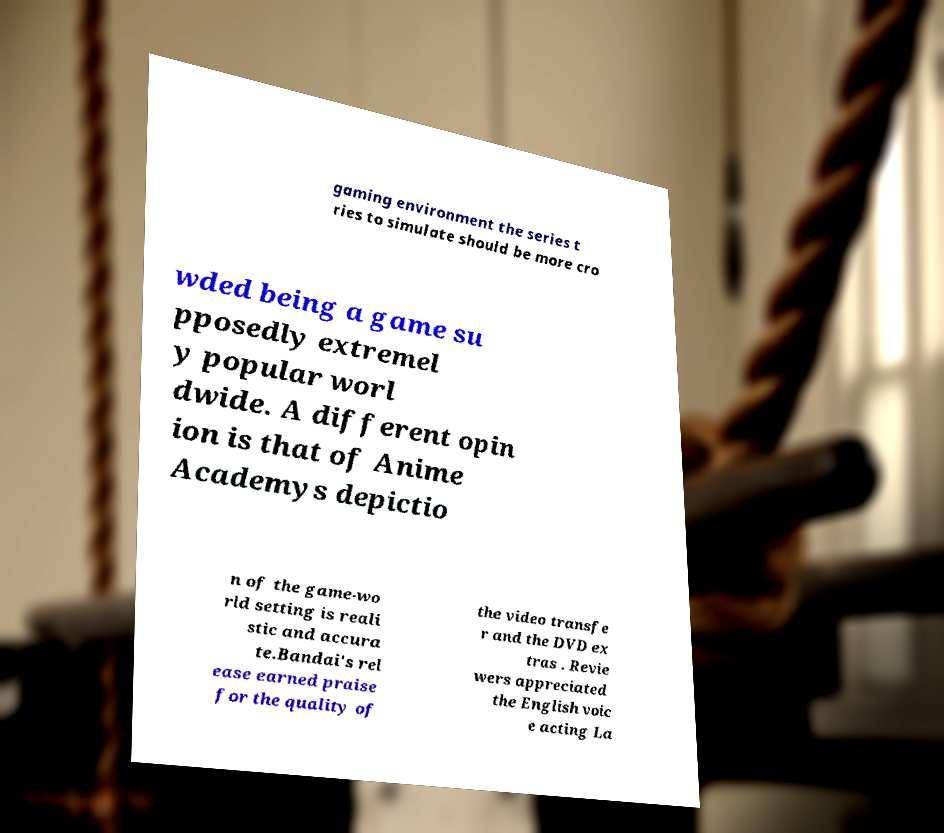I need the written content from this picture converted into text. Can you do that? gaming environment the series t ries to simulate should be more cro wded being a game su pposedly extremel y popular worl dwide. A different opin ion is that of Anime Academys depictio n of the game-wo rld setting is reali stic and accura te.Bandai's rel ease earned praise for the quality of the video transfe r and the DVD ex tras . Revie wers appreciated the English voic e acting La 